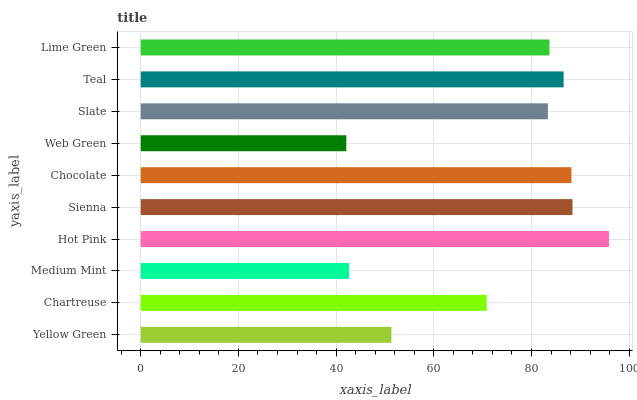Is Web Green the minimum?
Answer yes or no. Yes. Is Hot Pink the maximum?
Answer yes or no. Yes. Is Chartreuse the minimum?
Answer yes or no. No. Is Chartreuse the maximum?
Answer yes or no. No. Is Chartreuse greater than Yellow Green?
Answer yes or no. Yes. Is Yellow Green less than Chartreuse?
Answer yes or no. Yes. Is Yellow Green greater than Chartreuse?
Answer yes or no. No. Is Chartreuse less than Yellow Green?
Answer yes or no. No. Is Lime Green the high median?
Answer yes or no. Yes. Is Slate the low median?
Answer yes or no. Yes. Is Medium Mint the high median?
Answer yes or no. No. Is Web Green the low median?
Answer yes or no. No. 